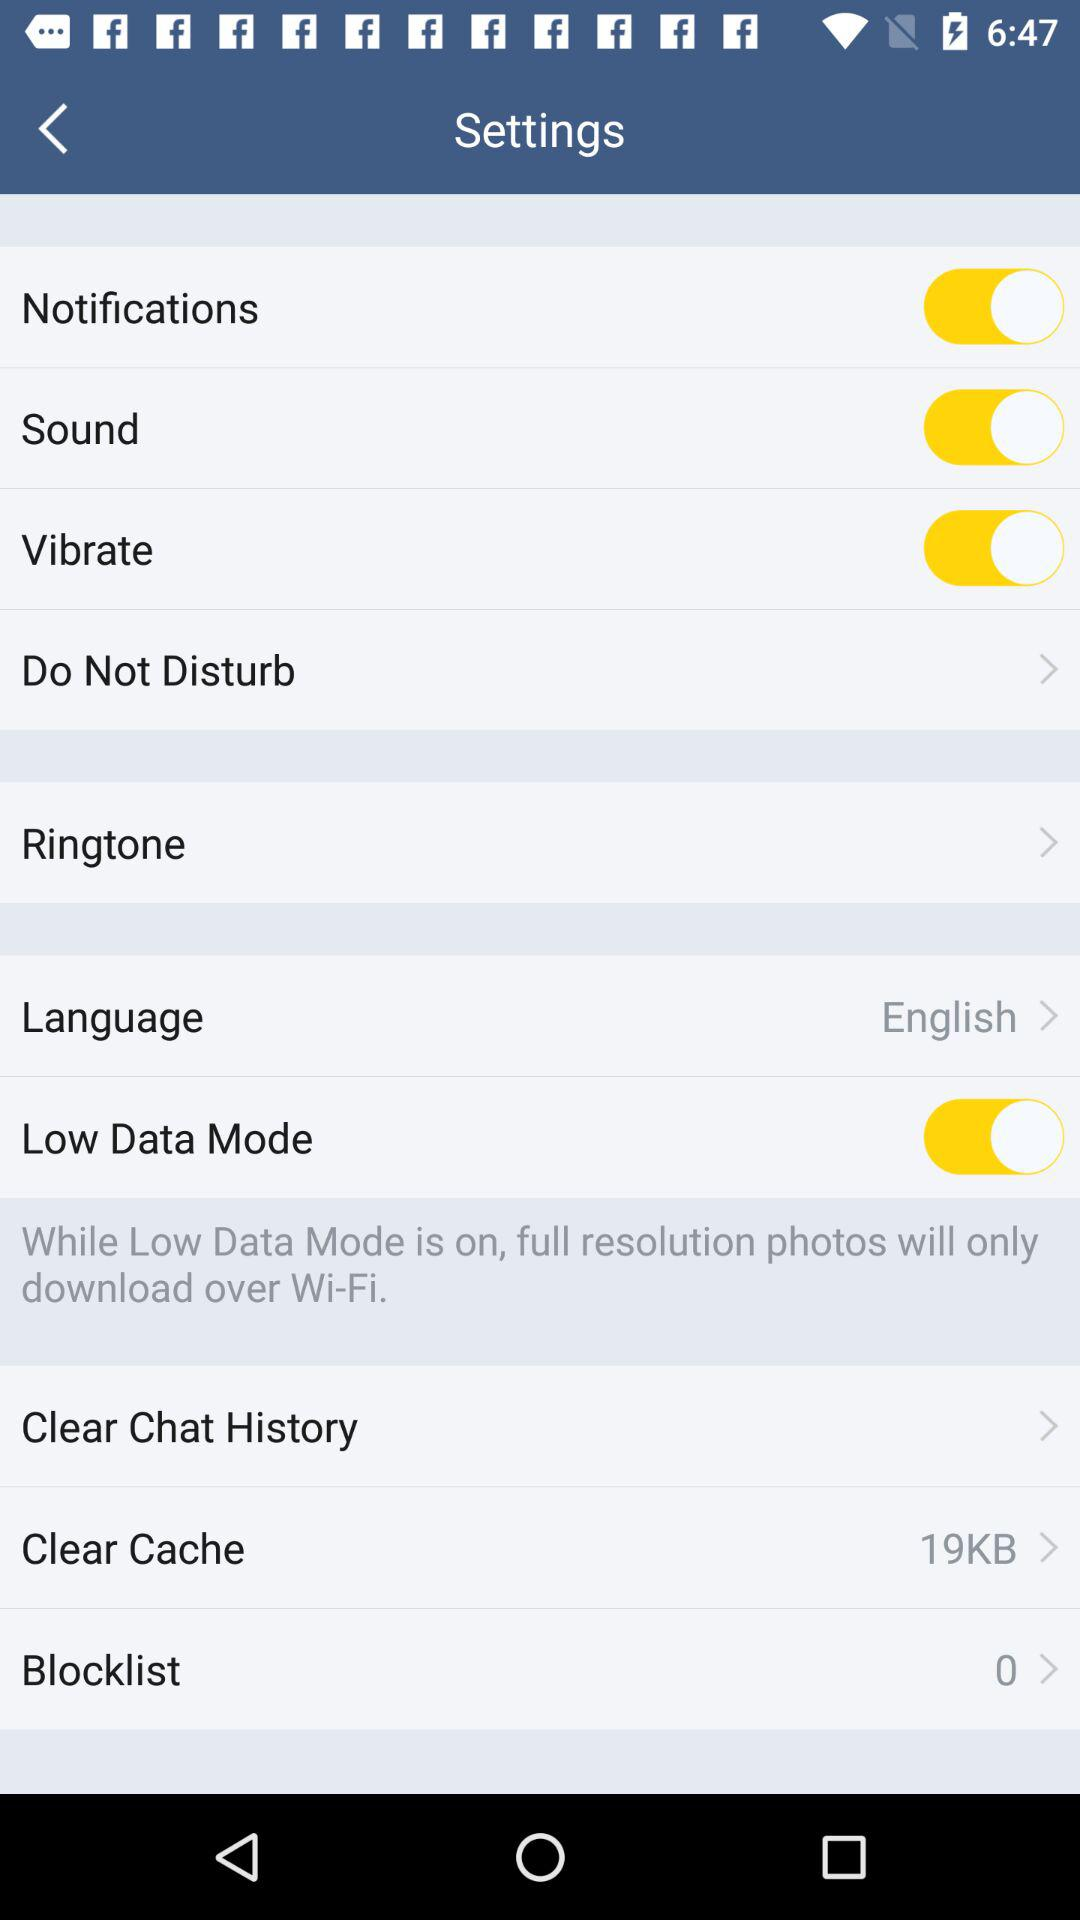What is the selected language? The selected language is English. 